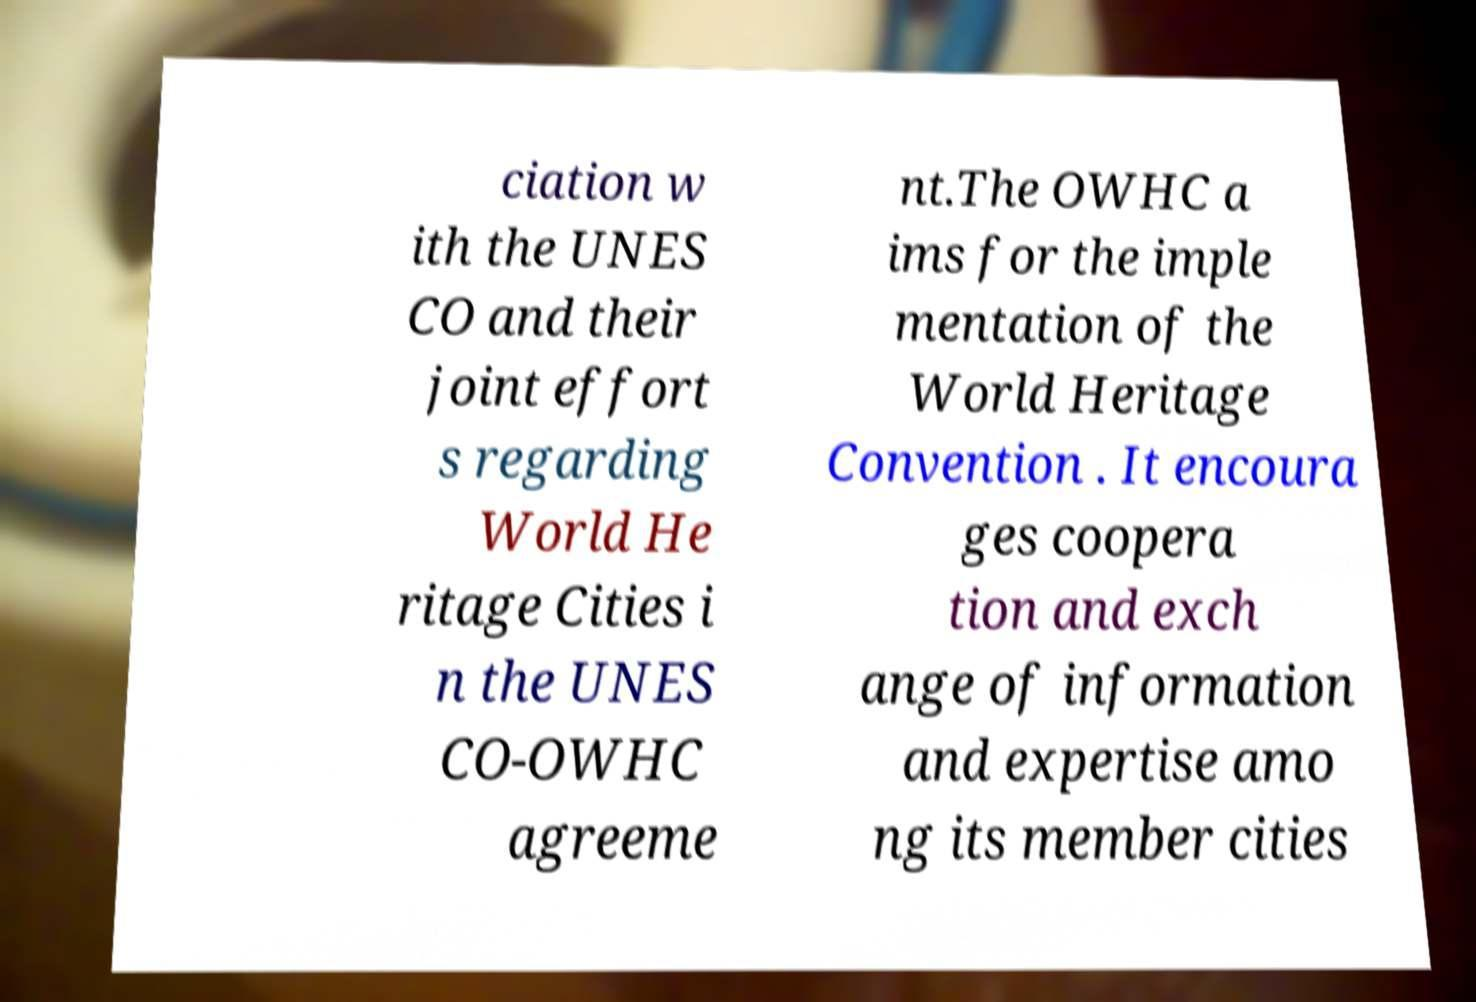Please read and relay the text visible in this image. What does it say? ciation w ith the UNES CO and their joint effort s regarding World He ritage Cities i n the UNES CO-OWHC agreeme nt.The OWHC a ims for the imple mentation of the World Heritage Convention . It encoura ges coopera tion and exch ange of information and expertise amo ng its member cities 